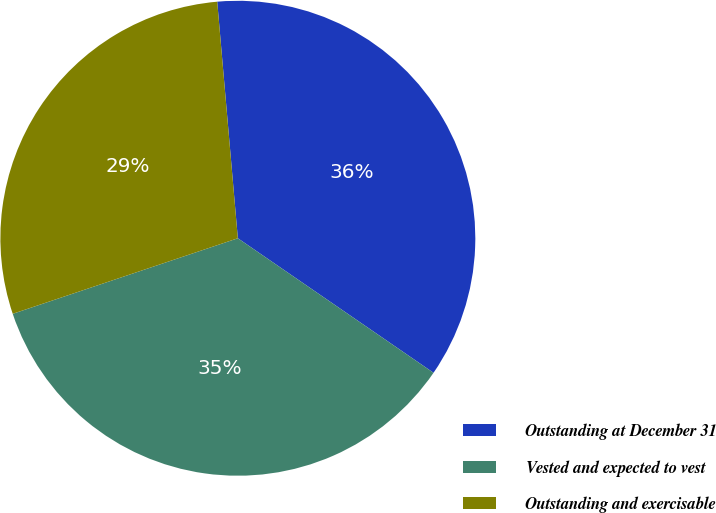Convert chart to OTSL. <chart><loc_0><loc_0><loc_500><loc_500><pie_chart><fcel>Outstanding at December 31<fcel>Vested and expected to vest<fcel>Outstanding and exercisable<nl><fcel>35.97%<fcel>35.26%<fcel>28.77%<nl></chart> 